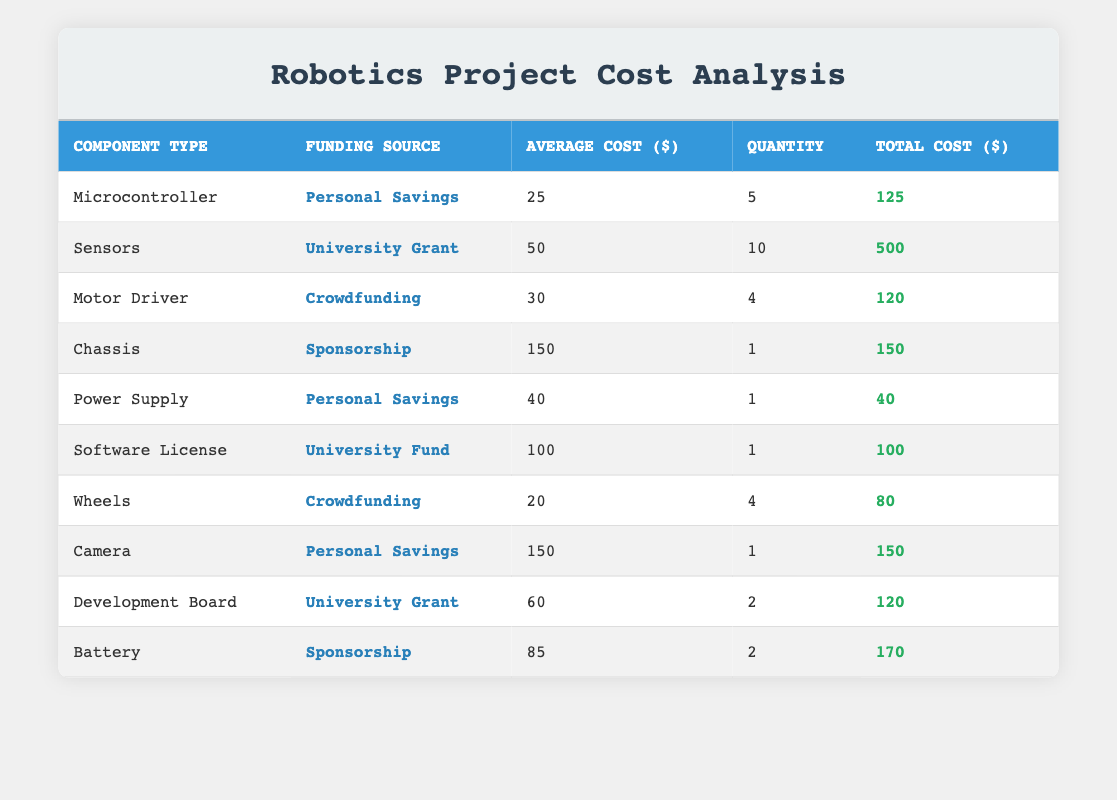What is the total cost for the Sensors component? The total cost for the Sensors component is directly provided in the table under the "Total Cost" column for the row that lists Sensors. The value is 500.
Answer: 500 What is the average cost of the components funded by Personal Savings? To find the average cost, we first identify the components funded by Personal Savings: Microcontroller ($25), Power Supply ($40), and Camera ($150). Then, we sum these costs (25 + 40 + 150 = 215) and divide by the number of components (3). Thus, the average cost is 215/3 = 71.67.
Answer: 71.67 Which component has the highest total cost and what is that cost? The component with the highest total cost can be found by looking at the "Total Cost" column. Upon checking, the Sensors component has the highest total cost of 500.
Answer: 500 Are there any components funded by both Crowdfunding and Sponsorship? Checking the table, we see that Crowdfunding is used for the Motor Driver and Wheels, while Sponsorship is used for the Chassis and Battery. Since there's no overlap, the answer is no.
Answer: No What is the total expenditure on components funded by the University Grant? The table shows two components funded by the University Grant: Sensors ($500) and Development Board ($120). Summing these gives us a total expenditure of 500 + 120 = 620.
Answer: 620 How many components have a total cost greater than 100? We check the "Total Cost" column for values greater than 100. The components with total costs greater than 100 are: Sensors (500), Chassis (150), Camera (150), and Battery (170). Therefore, there are 4 components.
Answer: 4 What is the average cost of components funded by Sponsorship? There are two components funded by Sponsorship: Chassis ($150) and Battery ($170). We sum these costs (150 + 170 = 320) and divide by the number of components (2), resulting in an average cost of 320/2 = 160.
Answer: 160 What is the total quantity of components funded by University Grant? There are two components that received funding from the University Grant: Sensors (quantity of 10) and Development Board (quantity of 2). Summing these yields a total quantity of 10 + 2 = 12.
Answer: 12 Is the total cost of the Motor Driver greater than that of the Power Supply? To determine this, we compare the two total costs. The Motor Driver has a total cost of 120 and the Power Supply has a total cost of 40. Since 120 is greater than 40, the answer is yes.
Answer: Yes 